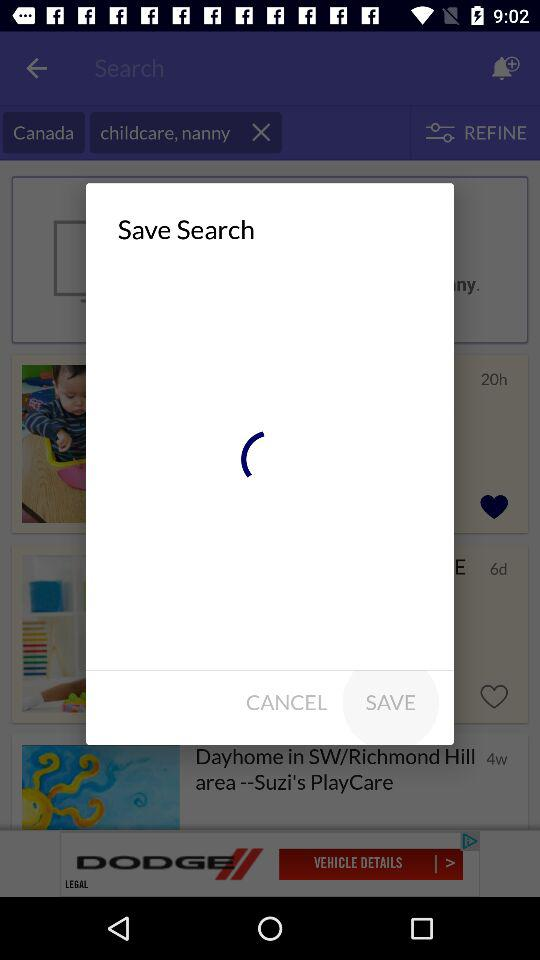What's the selected country? The selected country is Canada. 